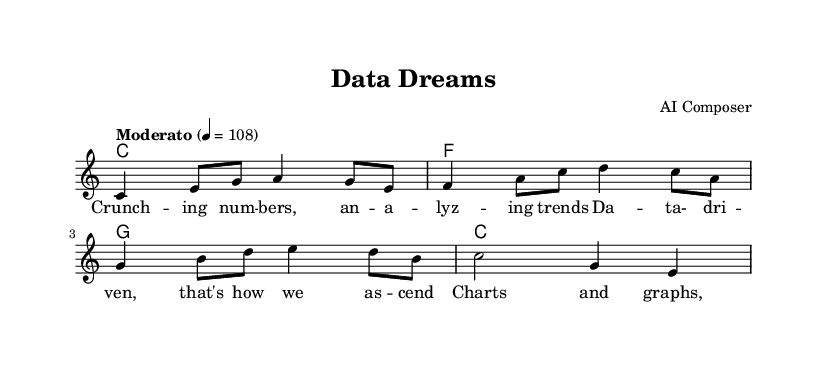What is the key signature of this music? The key signature is C major, which has no sharps or flats.
Answer: C major What is the time signature of this piece? The time signature shown in the music is 4/4, indicating four beats per measure.
Answer: 4/4 What is the tempo marking for this composition? The tempo marking is "Moderato," which indicates a moderate pace, specifically set at 108 beats per minute.
Answer: Moderato How many measures are in the melody? The melody consists of 4 measures as indicated by the grouping of beats.
Answer: 4 What type of instrument is indicated for playing the score? The score is written for a staff, which is typically used for instruments like piano or voice.
Answer: Staff What is the main theme highlighted in the lyrics? The lyrics emphasize data-driven decision making, showcasing how analysis helps in making informed choices.
Answer: Data-driven decision making How is harmony represented in this sheet music? Harmony is represented through chord symbols placed above the staff, indicating the chords to be played alongside the melody.
Answer: Chord symbols 